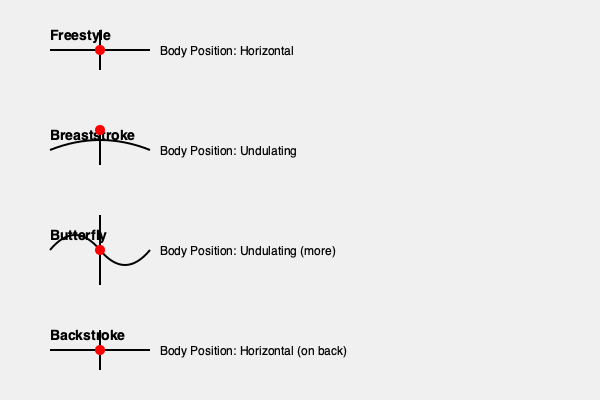Based on the body diagrams shown for different swimming strokes, which stroke is likely to be the most efficient in terms of energy expenditure and speed for long-distance events? To determine the most efficient swimming stroke for long-distance events, we need to consider the following factors:

1. Body position: A more horizontal body position creates less drag in the water.
2. Undulation: Less undulation typically requires less energy expenditure.
3. Continuous propulsion: Strokes that provide constant forward motion are more efficient.

Let's analyze each stroke:

1. Freestyle:
   - Horizontal body position
   - Minimal undulation
   - Continuous arm rotation providing constant propulsion

2. Breaststroke:
   - Slight undulation
   - Non-continuous propulsion (glide phase between strokes)
   - More resistance due to up-and-down movement

3. Butterfly:
   - Significant undulation
   - High energy expenditure due to whole-body movement
   - Powerful but not energy-efficient for long distances

4. Backstroke:
   - Horizontal body position (on back)
   - Minimal undulation
   - Continuous arm rotation providing constant propulsion

Comparing these strokes, Freestyle and Backstroke have the most horizontal body positions and minimal undulation. However, Freestyle has an advantage over Backstroke due to:

- Better visibility for navigation
- Easier breathing mechanics
- Slightly more natural body position

Therefore, Freestyle is generally considered the most efficient stroke for long-distance events, as it provides the best balance of speed and energy conservation.
Answer: Freestyle 